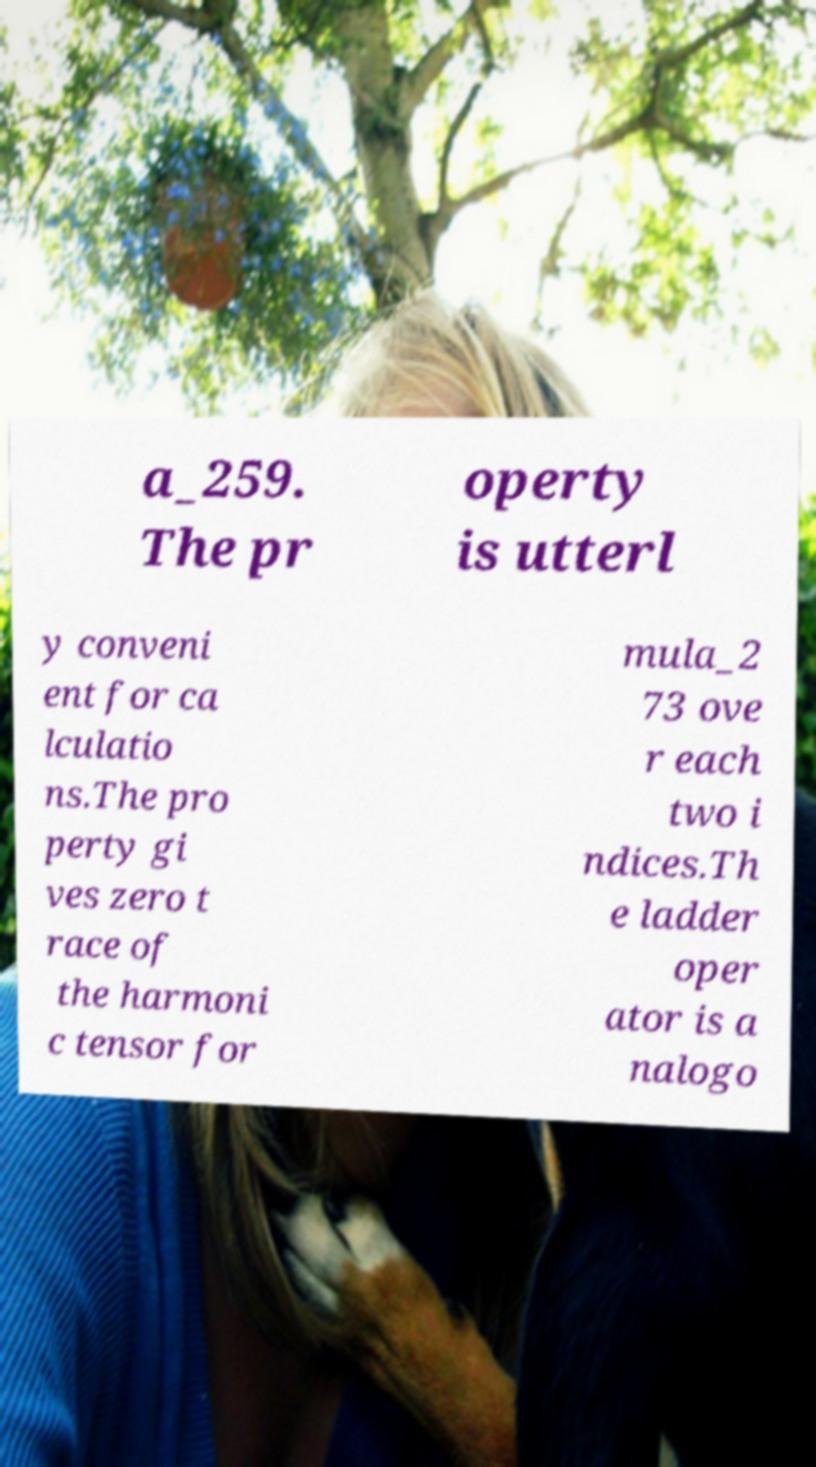Could you extract and type out the text from this image? a_259. The pr operty is utterl y conveni ent for ca lculatio ns.The pro perty gi ves zero t race of the harmoni c tensor for mula_2 73 ove r each two i ndices.Th e ladder oper ator is a nalogo 